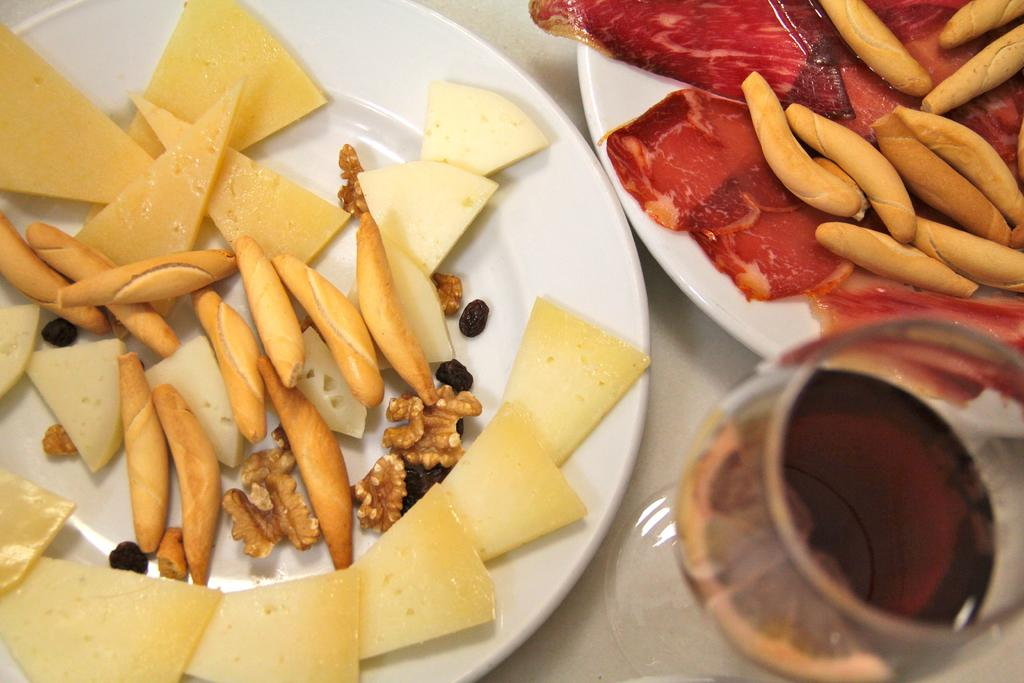How many plates are visible in the image? There are two plates in the image. What is on the plates? There are food items on the plates. What type of beverage is in the glass in the image? There is a glass of wine in the image. Where is the glass of wine located? The glass of wine is located in the bottom right side of the image. How many men are riding bikes in the image? There are no men or bikes present in the image. 